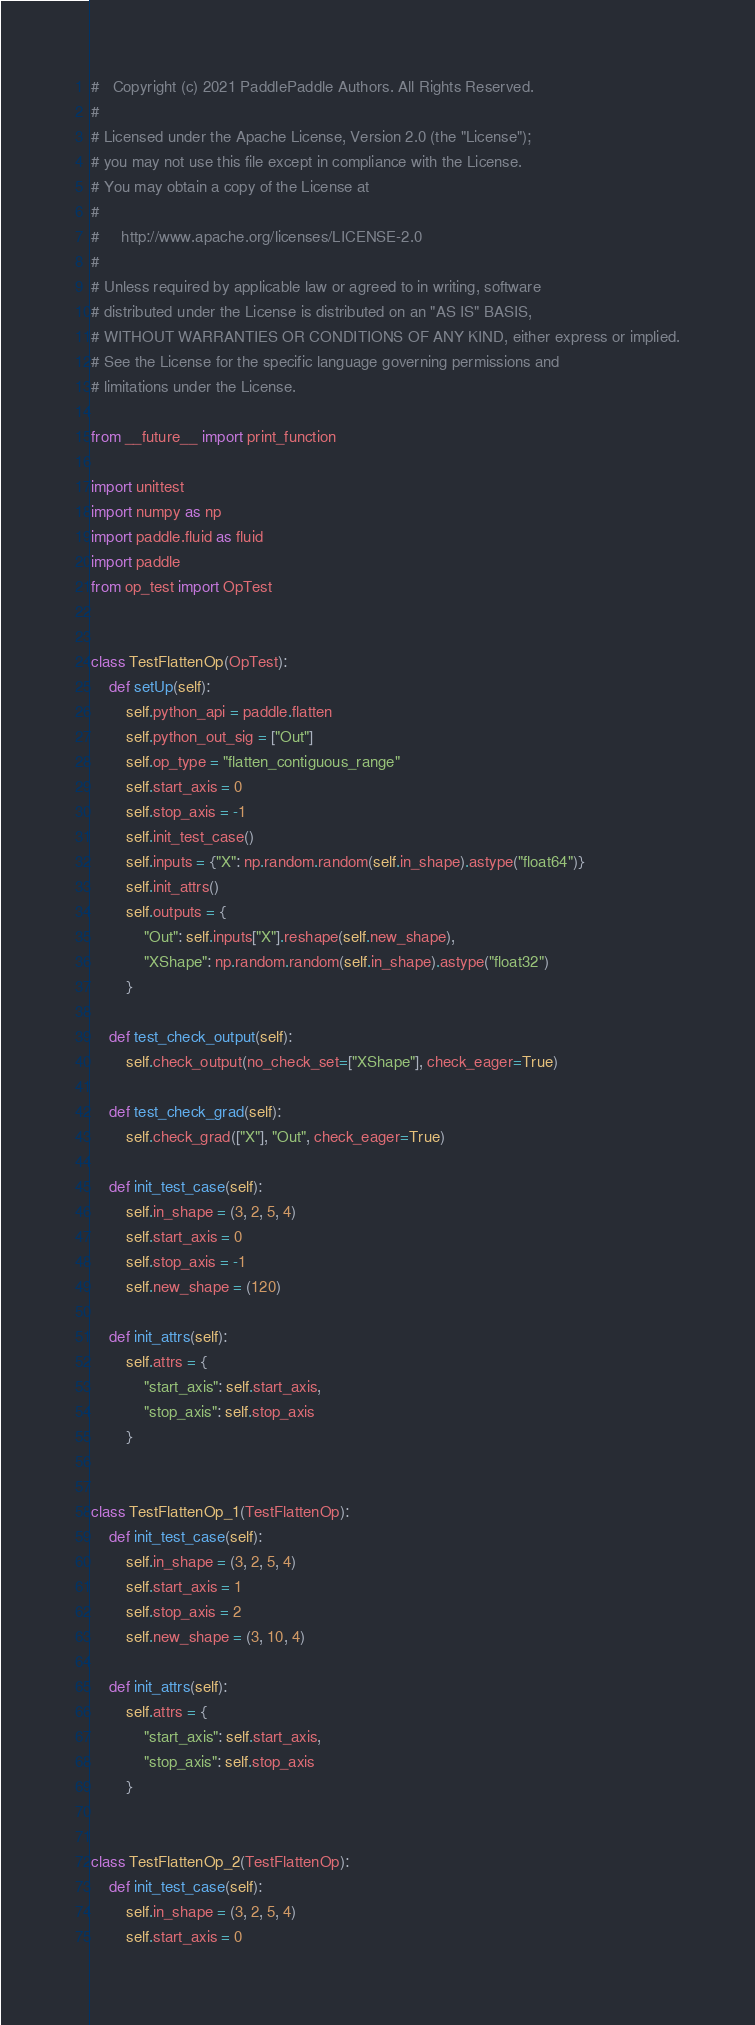Convert code to text. <code><loc_0><loc_0><loc_500><loc_500><_Python_>#   Copyright (c) 2021 PaddlePaddle Authors. All Rights Reserved.
#
# Licensed under the Apache License, Version 2.0 (the "License");
# you may not use this file except in compliance with the License.
# You may obtain a copy of the License at
#
#     http://www.apache.org/licenses/LICENSE-2.0
#
# Unless required by applicable law or agreed to in writing, software
# distributed under the License is distributed on an "AS IS" BASIS,
# WITHOUT WARRANTIES OR CONDITIONS OF ANY KIND, either express or implied.
# See the License for the specific language governing permissions and
# limitations under the License.

from __future__ import print_function

import unittest
import numpy as np
import paddle.fluid as fluid
import paddle
from op_test import OpTest


class TestFlattenOp(OpTest):
    def setUp(self):
        self.python_api = paddle.flatten
        self.python_out_sig = ["Out"]
        self.op_type = "flatten_contiguous_range"
        self.start_axis = 0
        self.stop_axis = -1
        self.init_test_case()
        self.inputs = {"X": np.random.random(self.in_shape).astype("float64")}
        self.init_attrs()
        self.outputs = {
            "Out": self.inputs["X"].reshape(self.new_shape),
            "XShape": np.random.random(self.in_shape).astype("float32")
        }

    def test_check_output(self):
        self.check_output(no_check_set=["XShape"], check_eager=True)

    def test_check_grad(self):
        self.check_grad(["X"], "Out", check_eager=True)

    def init_test_case(self):
        self.in_shape = (3, 2, 5, 4)
        self.start_axis = 0
        self.stop_axis = -1
        self.new_shape = (120)

    def init_attrs(self):
        self.attrs = {
            "start_axis": self.start_axis,
            "stop_axis": self.stop_axis
        }


class TestFlattenOp_1(TestFlattenOp):
    def init_test_case(self):
        self.in_shape = (3, 2, 5, 4)
        self.start_axis = 1
        self.stop_axis = 2
        self.new_shape = (3, 10, 4)

    def init_attrs(self):
        self.attrs = {
            "start_axis": self.start_axis,
            "stop_axis": self.stop_axis
        }


class TestFlattenOp_2(TestFlattenOp):
    def init_test_case(self):
        self.in_shape = (3, 2, 5, 4)
        self.start_axis = 0</code> 